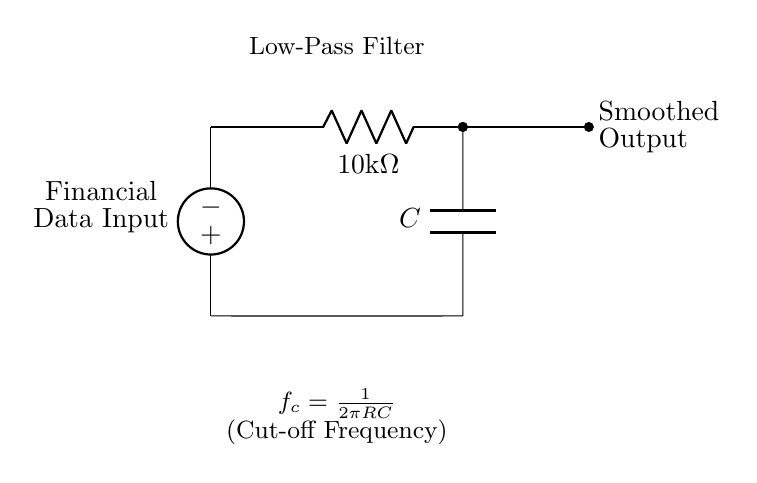What type of filter is represented in this circuit? The circuit shows a low-pass filter, which allows low-frequency signals to pass while attenuating high-frequency signals. This is indicated by the label "Low-Pass Filter" in the diagram.
Answer: Low-pass filter What is the resistance value in this circuit? The circuit diagram specifies a resistor labeled as "R" with a value of "10 kΩ". This is mentioned next to the resistor symbol.
Answer: 10 kΩ What is the role of the capacitor in this circuit? The capacitor, labeled "C", is essential for storing charge and determining the cutoff frequency of the low-pass filter. It works together with the resistor to filter out higher frequency noise from the financial data input.
Answer: Smoothing data What is the cutoff frequency formula shown in the circuit? The cutoff frequency, denoted as \( f_c \), is calculated using the formula \( \frac{1}{2\pi RC} \). This formula relates the resistor (R) and capacitor (C) values to the cutoff frequency.
Answer: \( \frac{1}{2\pi RC} \) What would be the effect of increasing the resistance value? Increasing resistance value would lower the cutoff frequency, allowing even fewer high-frequency signals to pass through, thereby further smoothing the output. This can be deduced from the cutoff frequency formula where R is in the denominator with C affecting the result.
Answer: Lower cutoff frequency What is indicated by the node named "Smoothed Output"? The "Smoothed Output" node indicates the output signal from the low-pass filter after the input financial data has been processed, reflecting how fluctuations in the data have been reduced. This is also a key feature of low-pass filter circuits.
Answer: Processed data output What happens to the circuit's behavior as the capacitance increases? Increasing the capacitance \( C \) would also lower the cutoff frequency, allowing even more low-frequency signals to pass through while filtering out higher frequencies more effectively. This is drawn from the formula for cutoff frequency where C is also in the denominator.
Answer: More low frequencies passed 